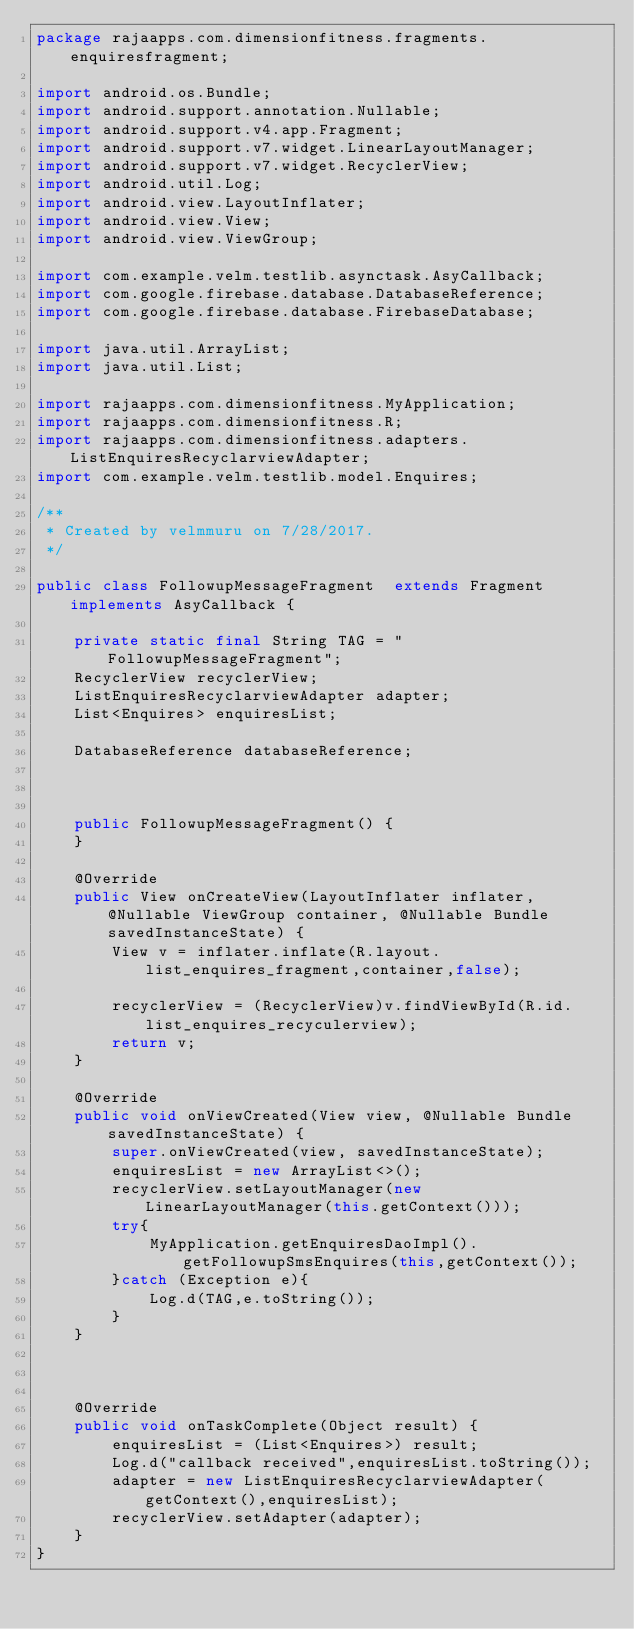<code> <loc_0><loc_0><loc_500><loc_500><_Java_>package rajaapps.com.dimensionfitness.fragments.enquiresfragment;

import android.os.Bundle;
import android.support.annotation.Nullable;
import android.support.v4.app.Fragment;
import android.support.v7.widget.LinearLayoutManager;
import android.support.v7.widget.RecyclerView;
import android.util.Log;
import android.view.LayoutInflater;
import android.view.View;
import android.view.ViewGroup;

import com.example.velm.testlib.asynctask.AsyCallback;
import com.google.firebase.database.DatabaseReference;
import com.google.firebase.database.FirebaseDatabase;

import java.util.ArrayList;
import java.util.List;

import rajaapps.com.dimensionfitness.MyApplication;
import rajaapps.com.dimensionfitness.R;
import rajaapps.com.dimensionfitness.adapters.ListEnquiresRecyclarviewAdapter;
import com.example.velm.testlib.model.Enquires;

/**
 * Created by velmmuru on 7/28/2017.
 */

public class FollowupMessageFragment  extends Fragment implements AsyCallback {

    private static final String TAG = "FollowupMessageFragment";
    RecyclerView recyclerView;
    ListEnquiresRecyclarviewAdapter adapter;
    List<Enquires> enquiresList;

    DatabaseReference databaseReference;



    public FollowupMessageFragment() {
    }

    @Override
    public View onCreateView(LayoutInflater inflater, @Nullable ViewGroup container, @Nullable Bundle savedInstanceState) {
        View v = inflater.inflate(R.layout.list_enquires_fragment,container,false);

        recyclerView = (RecyclerView)v.findViewById(R.id.list_enquires_recyculerview);
        return v;
    }

    @Override
    public void onViewCreated(View view, @Nullable Bundle savedInstanceState) {
        super.onViewCreated(view, savedInstanceState);
        enquiresList = new ArrayList<>();
        recyclerView.setLayoutManager(new LinearLayoutManager(this.getContext()));
        try{
            MyApplication.getEnquiresDaoImpl().getFollowupSmsEnquires(this,getContext());
        }catch (Exception e){
            Log.d(TAG,e.toString());
        }
    }



    @Override
    public void onTaskComplete(Object result) {
        enquiresList = (List<Enquires>) result;
        Log.d("callback received",enquiresList.toString());
        adapter = new ListEnquiresRecyclarviewAdapter(getContext(),enquiresList);
        recyclerView.setAdapter(adapter);
    }
}
</code> 